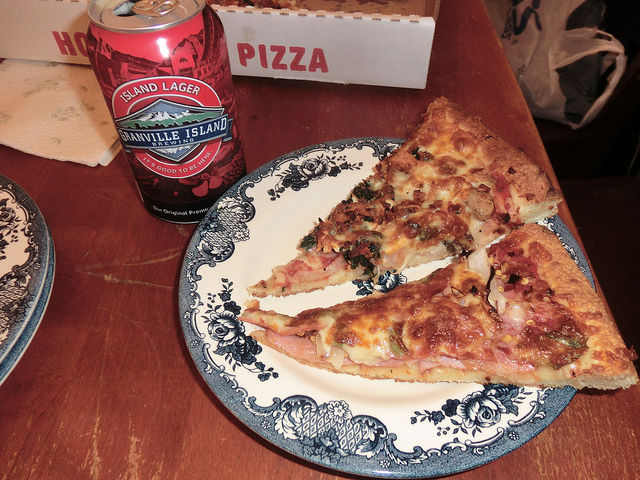Please identify all text content in this image. PIZZA ISLAND GRANVILLE ISLAND LAGER HO 